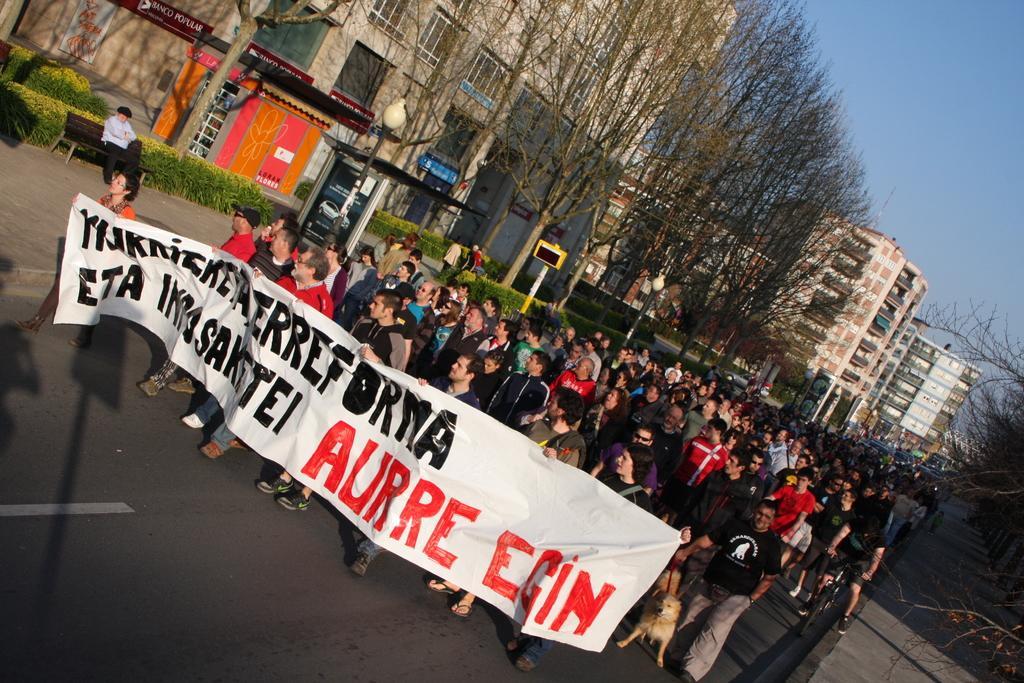In one or two sentences, can you explain what this image depicts? In the foreground of this image, these persons holding a banner are walking on the road. In the background, there is the crowd, trees, buildings, poles, plants and a man sitting on the bench and on the top right side, there is the sky. 